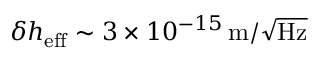<formula> <loc_0><loc_0><loc_500><loc_500>\delta h _ { e f f } \sim 3 \times 1 0 ^ { - 1 5 } \, m / \sqrt { H z }</formula> 